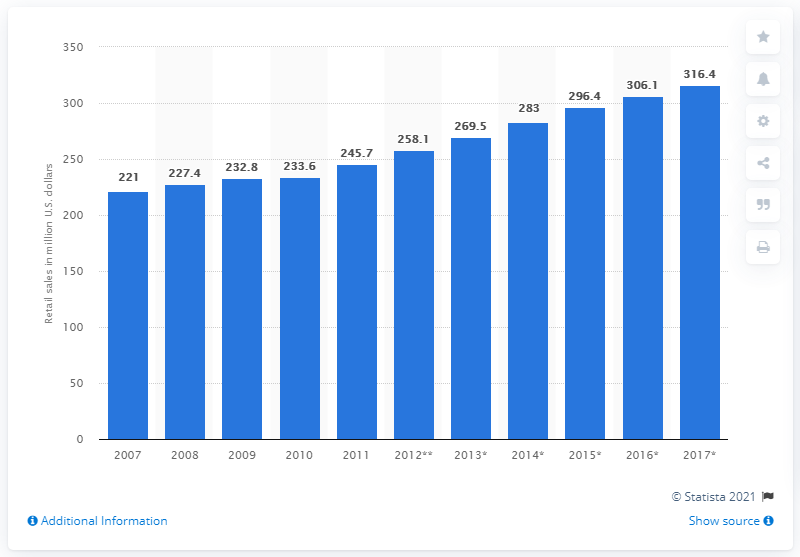Highlight a few significant elements in this photo. The value of the packaged organic beverages market in the United States in 2014 was 296.4 million dollars. The packaged organic beverage market began to grow in the UK in the year 2007. 